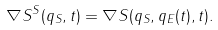Convert formula to latex. <formula><loc_0><loc_0><loc_500><loc_500>\nabla S ^ { S } ( q _ { S } , t ) = \nabla S ( q _ { S } , q _ { E } ( t ) , t ) .</formula> 